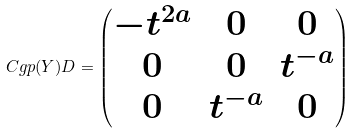<formula> <loc_0><loc_0><loc_500><loc_500>C g p ( Y ) D = \begin{pmatrix} - t ^ { 2 a } & 0 & 0 \\ 0 & 0 & t ^ { - a } \\ 0 & t ^ { - a } & 0 \end{pmatrix}</formula> 